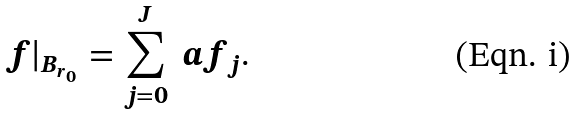Convert formula to latex. <formula><loc_0><loc_0><loc_500><loc_500>f | _ { B _ { r _ { 0 } } } = \sum _ { j = 0 } ^ { J } \ a { f _ { j } } .</formula> 